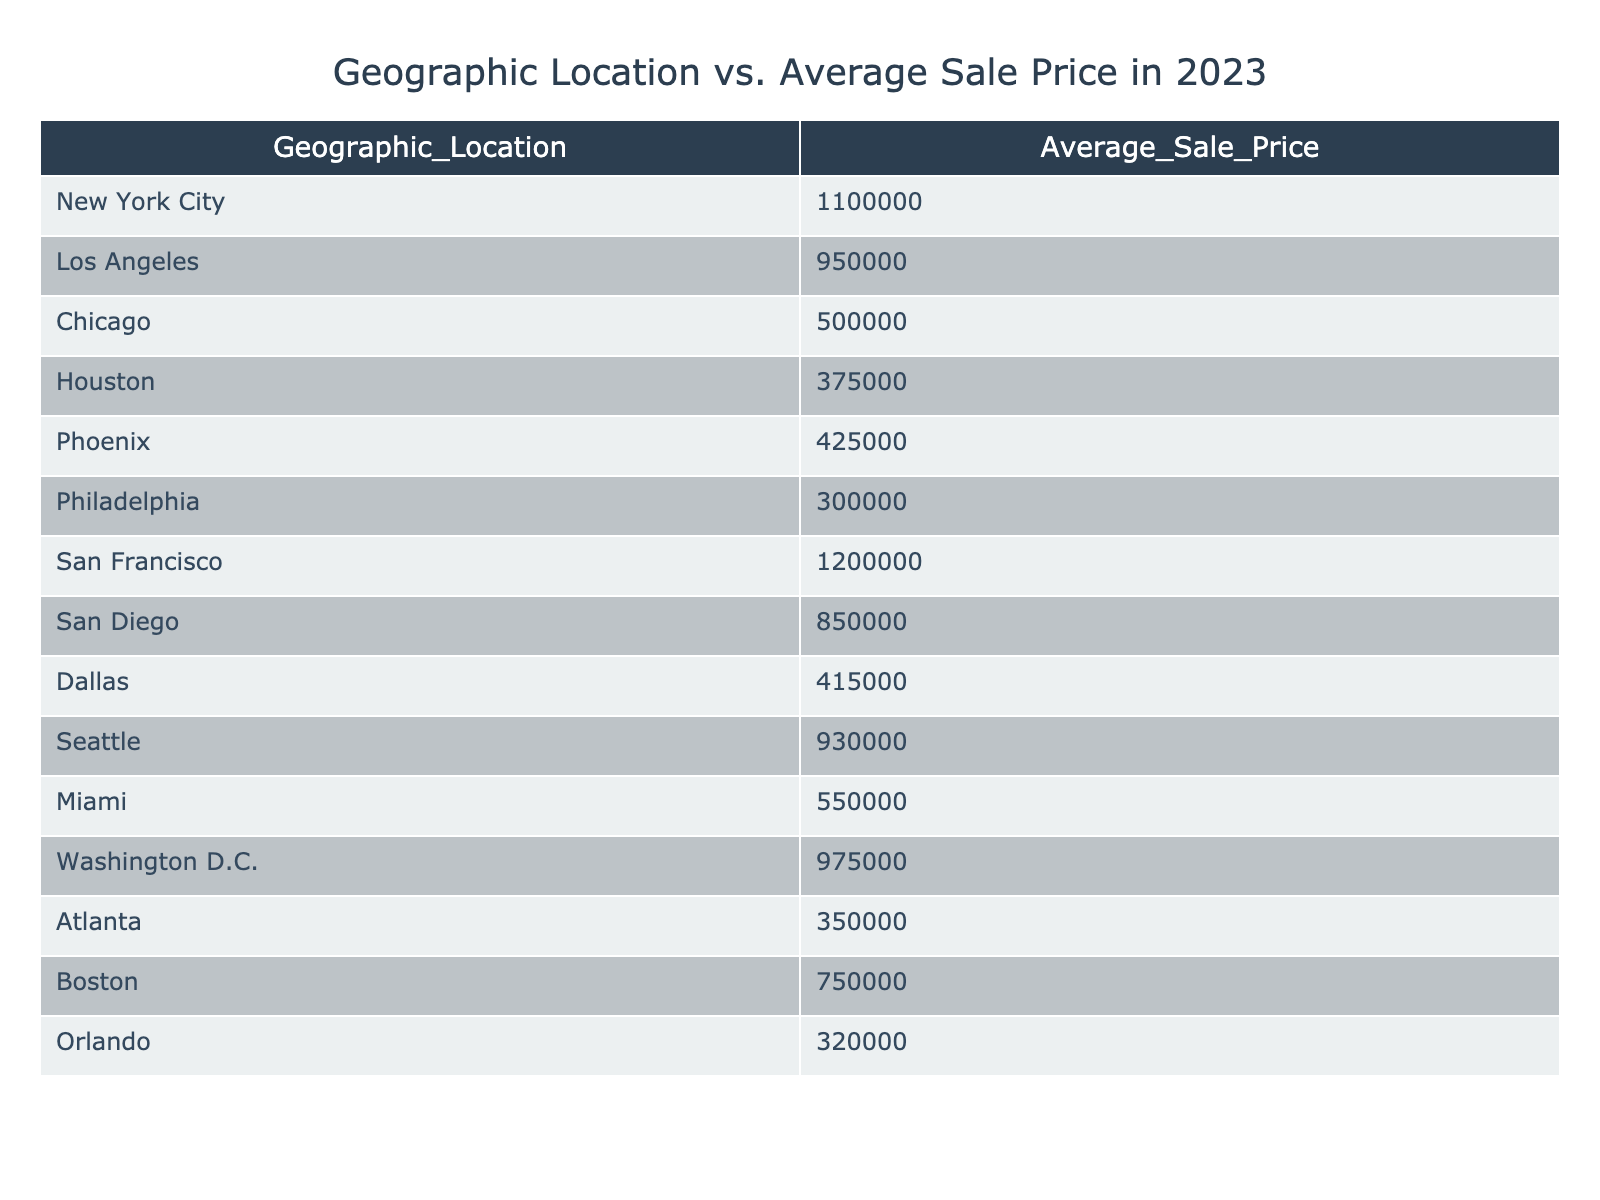What is the Average Sale Price in New York City? The table directly shows the Average Sale Price for New York City as 1,100,000.
Answer: 1,100,000 Which city has the lowest Average Sale Price? By reviewing the Average Sale Prices listed in the table, Houston has the lowest price at 375,000.
Answer: Houston What is the difference in Average Sale Price between San Francisco and Chicago? The Average Sale Price for San Francisco is 1,200,000, and for Chicago, it is 500,000. The difference is 1,200,000 - 500,000 = 700,000.
Answer: 700,000 Is the Average Sale Price in Miami higher than that in Boston? The Average Sale Price in Miami is 550,000, while in Boston it is 750,000. Since 550,000 is less than 750,000, the statement is false.
Answer: No What is the median Average Sale Price among the listed cities? The Average Sale Prices in ascending order are: 300,000 (Philadelphia), 320,000 (Orlando), 350,000 (Atlanta), 375,000 (Houston), 415,000 (Dallas), 425,000 (Phoenix), 500,000 (Chicago), 550,000 (Miami), 750,000 (Boston), 850,000 (San Diego), 930,000 (Seattle), 950,000 (Los Angeles), 975,000 (Washington D.C.), 1,100,000 (New York City), 1,200,000 (San Francisco). Since there are 14 cities, the median will be the average of the 7th (500,000) and 8th (550,000) values: (500,000 + 550,000) / 2 = 525,000.
Answer: 525,000 Which two cities have an Average Sale Price higher than 900,000? According to the table, San Francisco (1,200,000) and New York City (1,100,000) are the only two cities with Average Sale Prices above 900,000.
Answer: San Francisco and New York City 